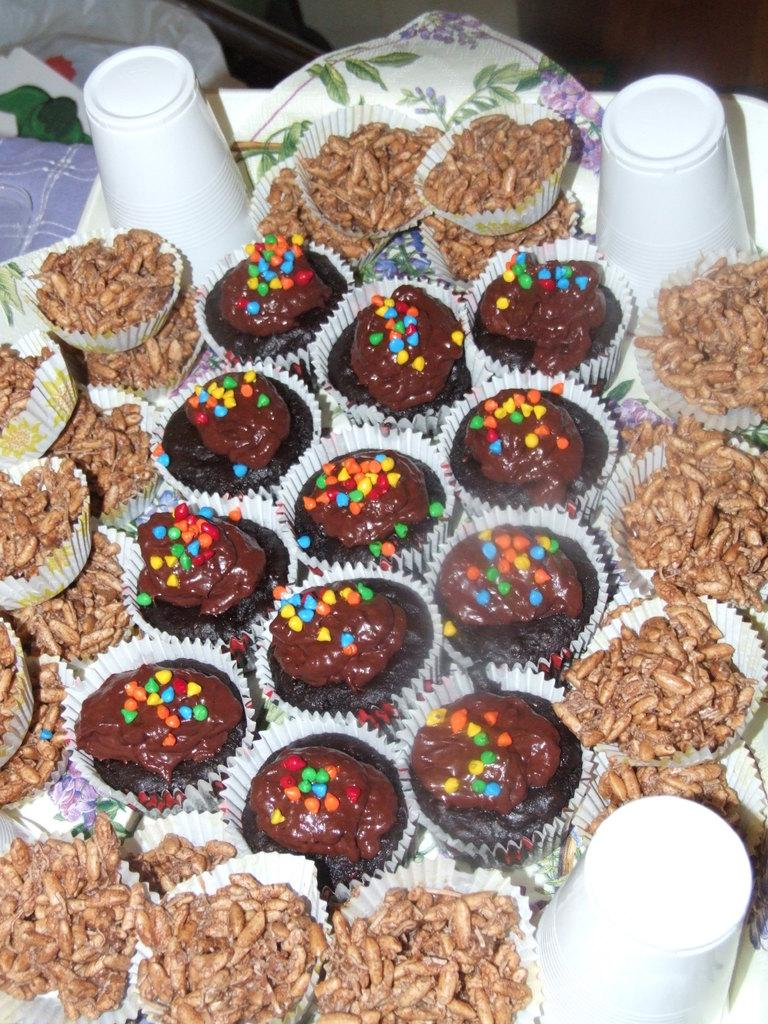What piece of furniture is present in the image? There is a table in the image. What objects are placed on the table? There are cups and food items on papers on the table. Can you describe the food items on the table? There are cupcakes with chocolate cream and colored choco chips on the table. What sense does the girl use to enjoy the rhythm of the chocolate chips in the image? There is no girl present in the image, and chocolate chips do not have a rhythm. 